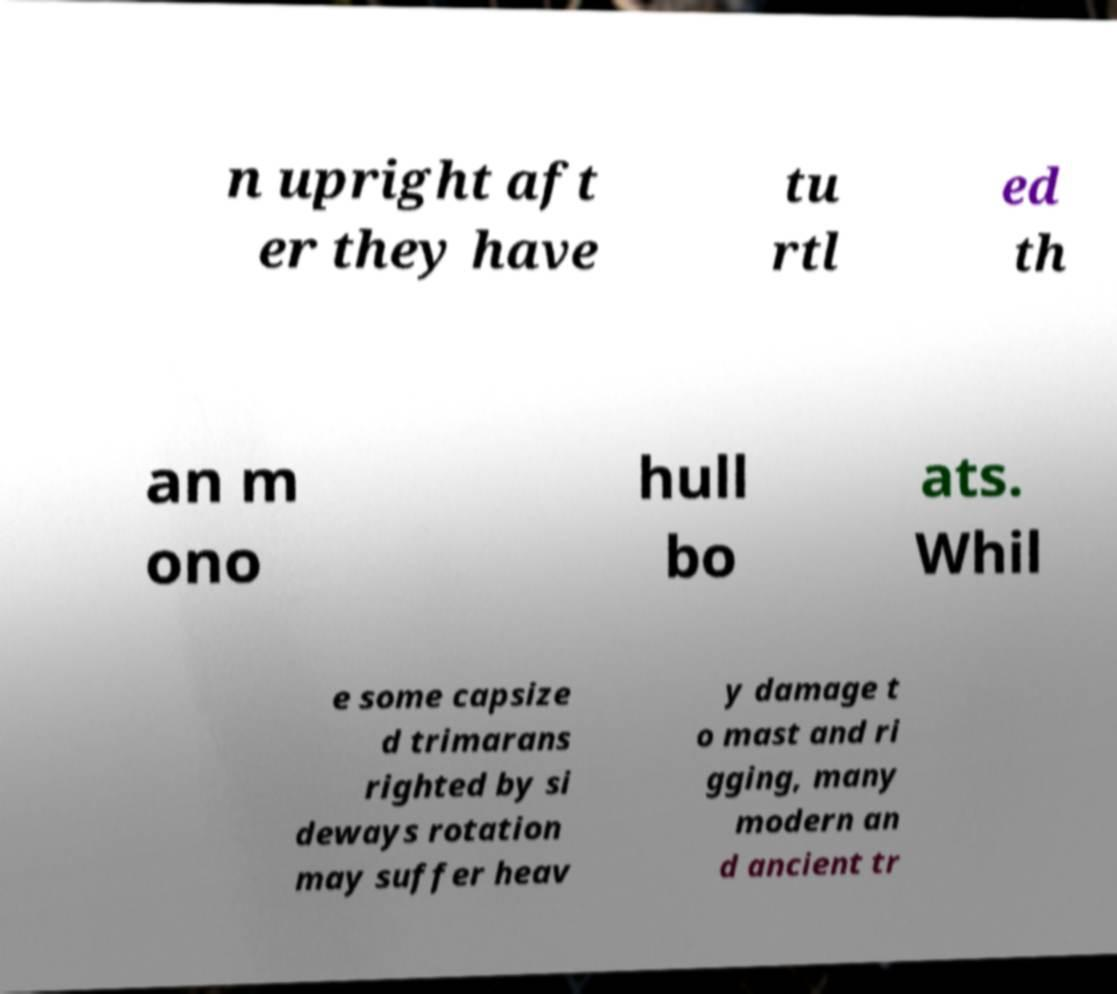Can you accurately transcribe the text from the provided image for me? n upright aft er they have tu rtl ed th an m ono hull bo ats. Whil e some capsize d trimarans righted by si deways rotation may suffer heav y damage t o mast and ri gging, many modern an d ancient tr 